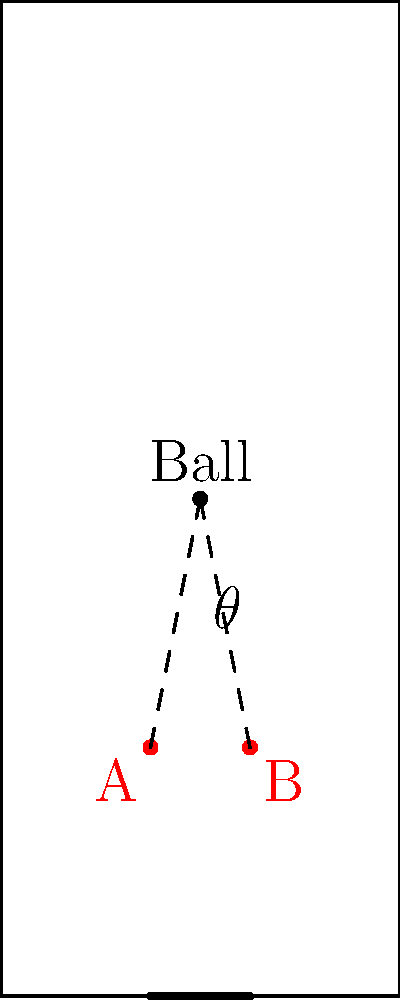In a free-kick scenario, you're positioning a defensive wall to block a shot. The ball is placed 20 meters from the goal line, centered. If the goal is 8 meters wide and you want to create a wall that covers a 30-degree angle from the ball's perspective, how far from the goal line should you place the wall, assuming it spans the full width of the goal? To solve this problem, we'll use trigonometry:

1) First, let's identify what we know:
   - The ball is 20 meters from the goal line
   - The goal is 8 meters wide
   - We want the wall to cover a 30-degree angle

2) We can split this into two right triangles. The angle we're interested in is half of 30°, so 15°.

3) In this right triangle:
   - The opposite side is half the goal width: 4 meters
   - The angle is 15°
   - We need to find the adjacent side (distance from goal line to wall)

4) We can use the tangent function:
   
   $\tan(15°) = \frac{\text{opposite}}{\text{adjacent}} = \frac{4}{\text{x}}$

5) Solving for x:
   
   $x = \frac{4}{\tan(15°)}$

6) Calculate:
   
   $x \approx 14.93$ meters

7) Therefore, the wall should be placed approximately 14.93 meters from the goal line.

8) To verify: 
   - Distance from ball to wall: $20 - 14.93 = 5.07$ meters
   - Angle check: $\tan^{-1}(\frac{4}{5.07}) \times 2 \approx 30°$

This placement ensures the wall covers a 30-degree angle from the ball's perspective.
Answer: 14.93 meters from the goal line 